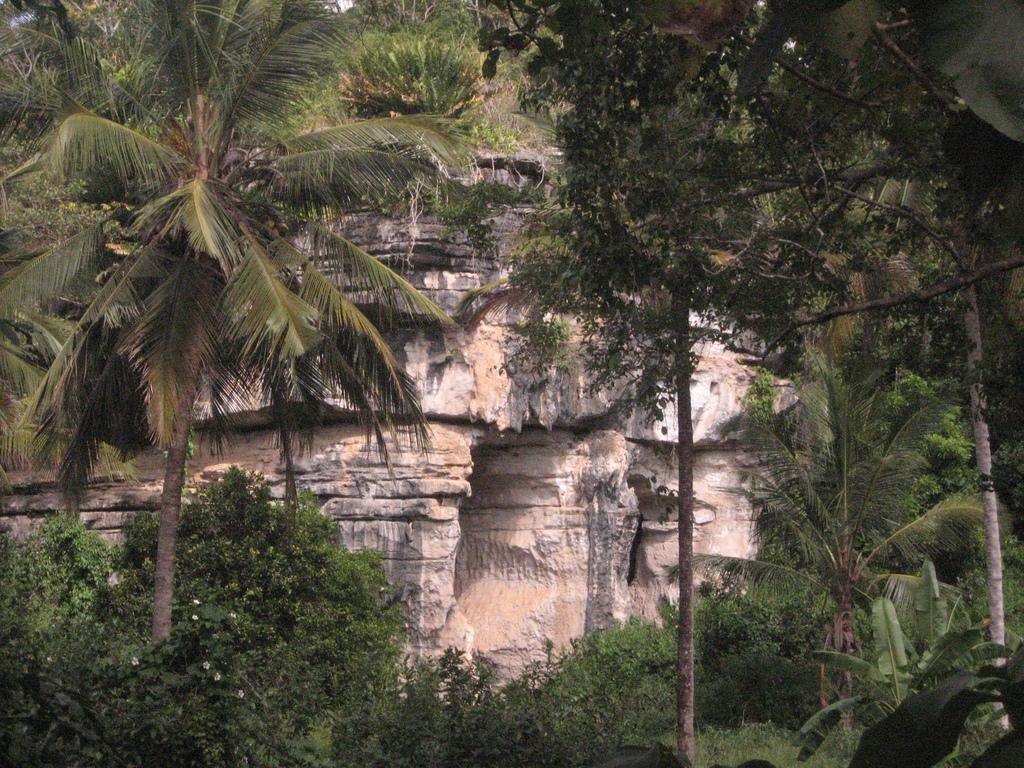Please provide a concise description of this image. In this image we can see the Amboni caves, some plants with flowers, some trees, bushes, plants and grass on the surface. 